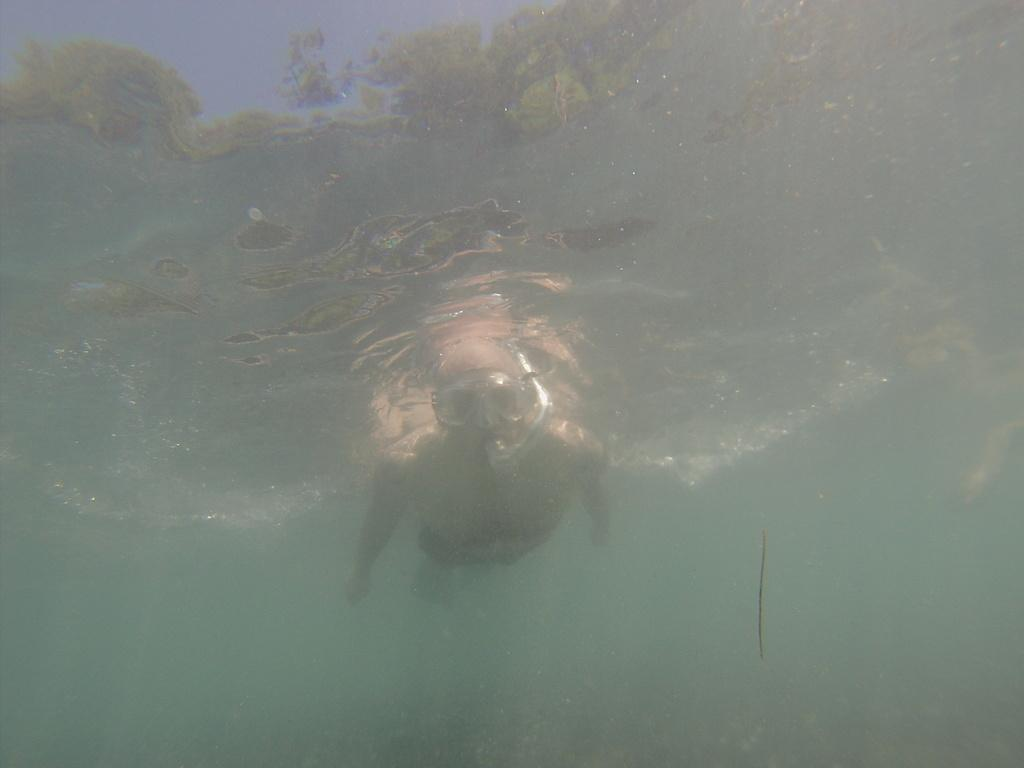What is the person in the image doing? The person is in the water. Can you describe the "thing" that is present in the image? Unfortunately, the provided facts do not specify the nature or characteristics of the "thing." What type of fruit can be seen hanging from the alley in the image? There is no alley or fruit present in the image. 